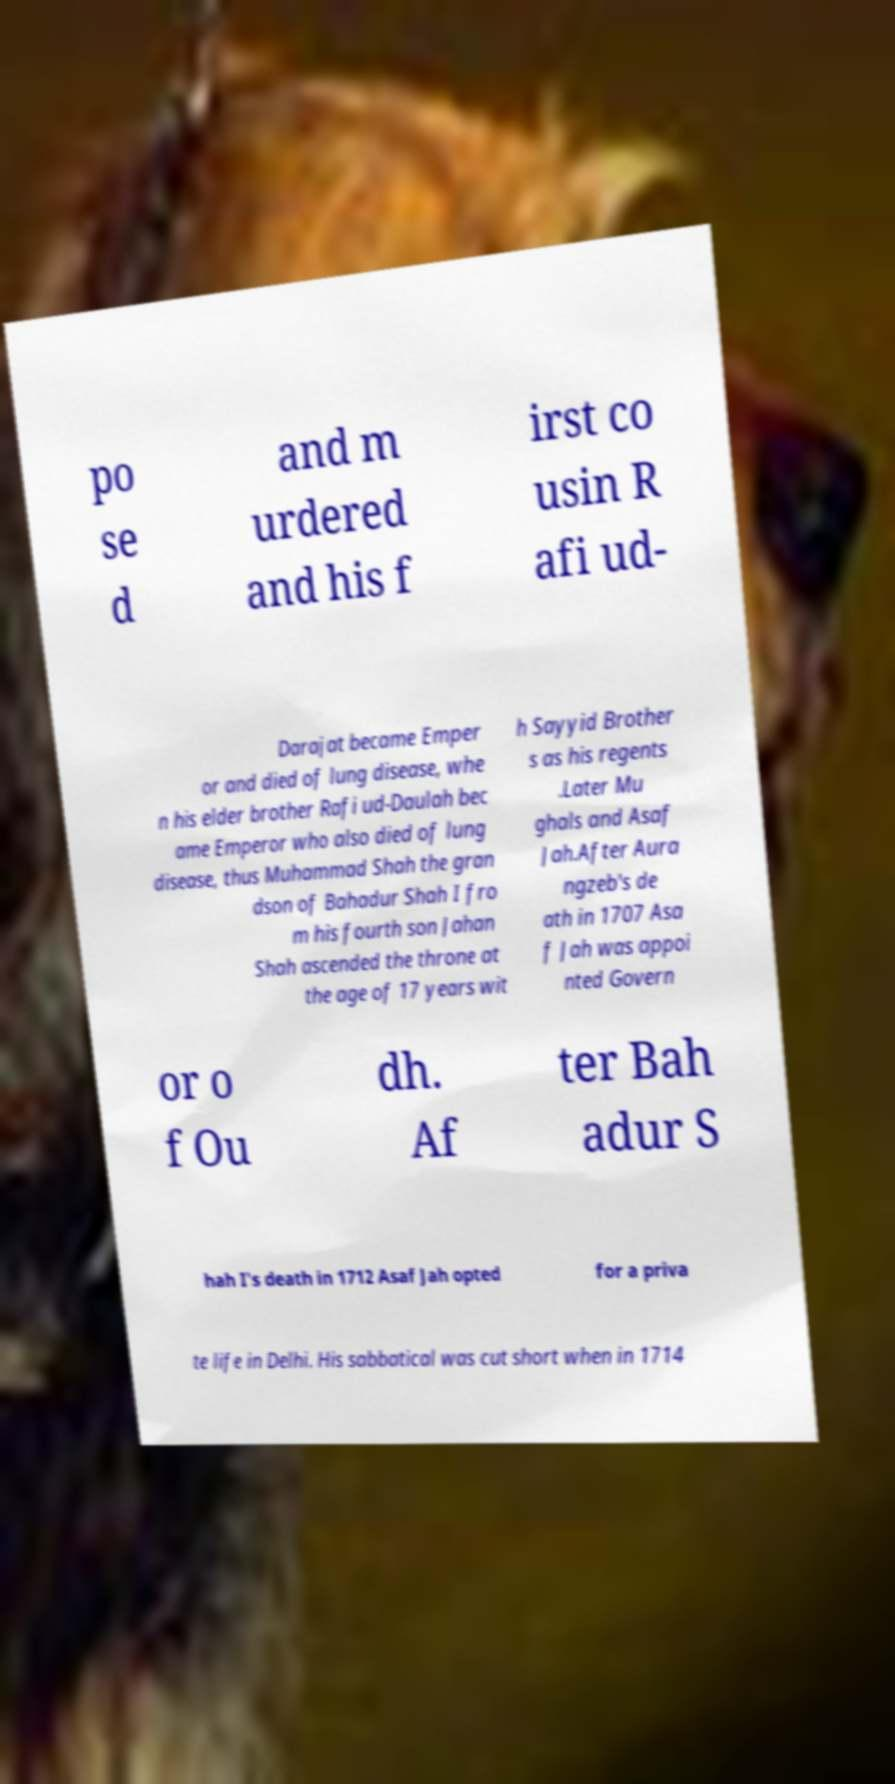Please read and relay the text visible in this image. What does it say? po se d and m urdered and his f irst co usin R afi ud- Darajat became Emper or and died of lung disease, whe n his elder brother Rafi ud-Daulah bec ame Emperor who also died of lung disease, thus Muhammad Shah the gran dson of Bahadur Shah I fro m his fourth son Jahan Shah ascended the throne at the age of 17 years wit h Sayyid Brother s as his regents .Later Mu ghals and Asaf Jah.After Aura ngzeb's de ath in 1707 Asa f Jah was appoi nted Govern or o f Ou dh. Af ter Bah adur S hah I's death in 1712 Asaf Jah opted for a priva te life in Delhi. His sabbatical was cut short when in 1714 